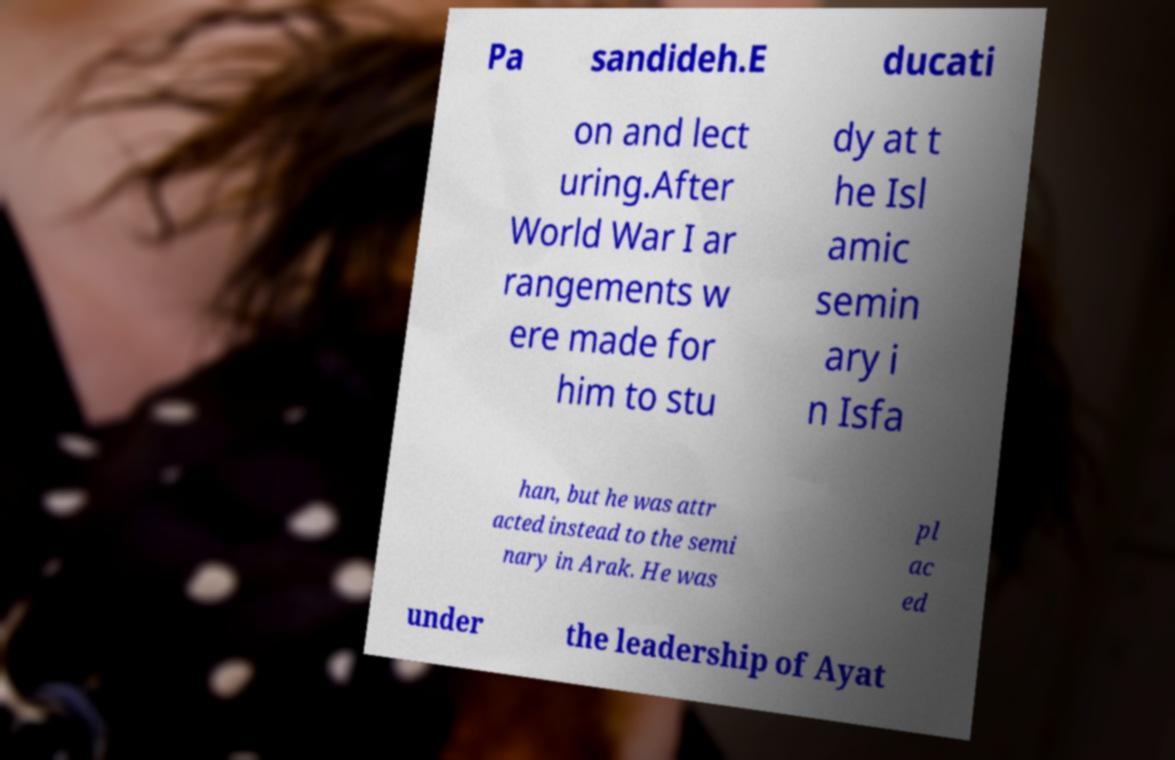What messages or text are displayed in this image? I need them in a readable, typed format. Pa sandideh.E ducati on and lect uring.After World War I ar rangements w ere made for him to stu dy at t he Isl amic semin ary i n Isfa han, but he was attr acted instead to the semi nary in Arak. He was pl ac ed under the leadership of Ayat 